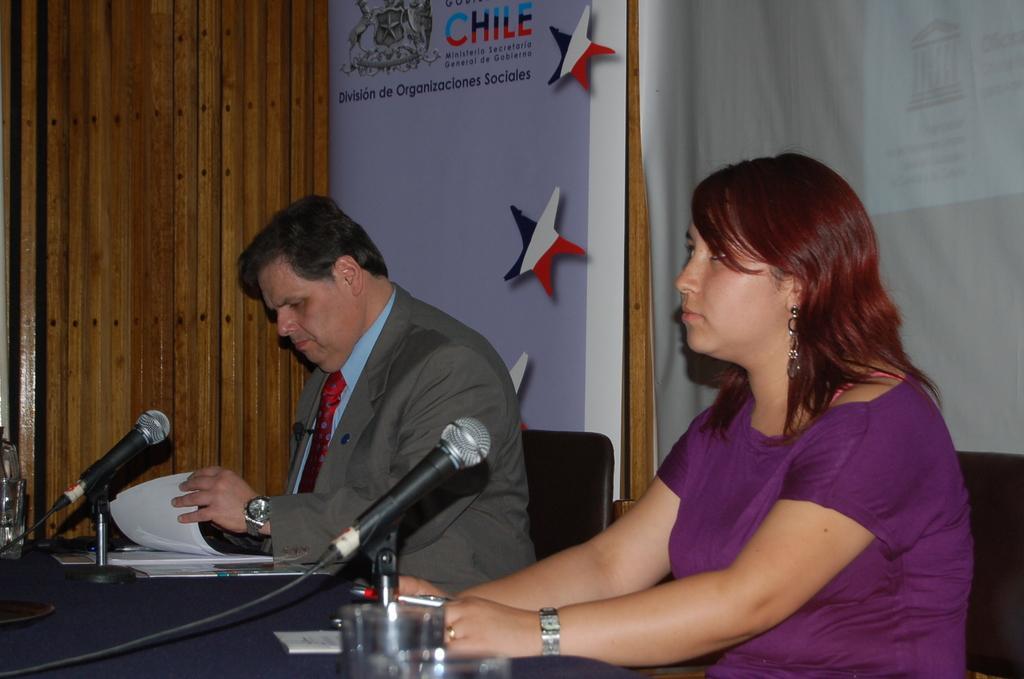Please provide a concise description of this image. At the bottom of the image there is a table. On the table we can see a cloth, mics, papers, glasses. Beside a table we can see two persons are sitting on the chairs. In the background of the image we can see the wall and boards. 